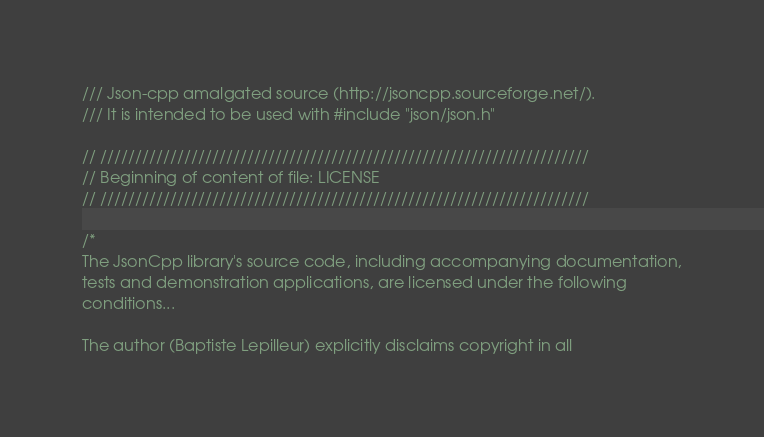Convert code to text. <code><loc_0><loc_0><loc_500><loc_500><_C++_>/// Json-cpp amalgated source (http://jsoncpp.sourceforge.net/).
/// It is intended to be used with #include "json/json.h"

// //////////////////////////////////////////////////////////////////////
// Beginning of content of file: LICENSE
// //////////////////////////////////////////////////////////////////////

/*
The JsonCpp library's source code, including accompanying documentation,
tests and demonstration applications, are licensed under the following
conditions...

The author (Baptiste Lepilleur) explicitly disclaims copyright in all</code> 